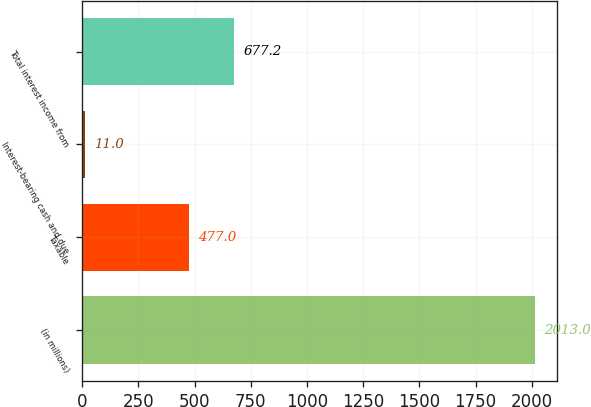Convert chart to OTSL. <chart><loc_0><loc_0><loc_500><loc_500><bar_chart><fcel>(in millions)<fcel>Taxable<fcel>Interest-bearing cash and due<fcel>Total interest income from<nl><fcel>2013<fcel>477<fcel>11<fcel>677.2<nl></chart> 